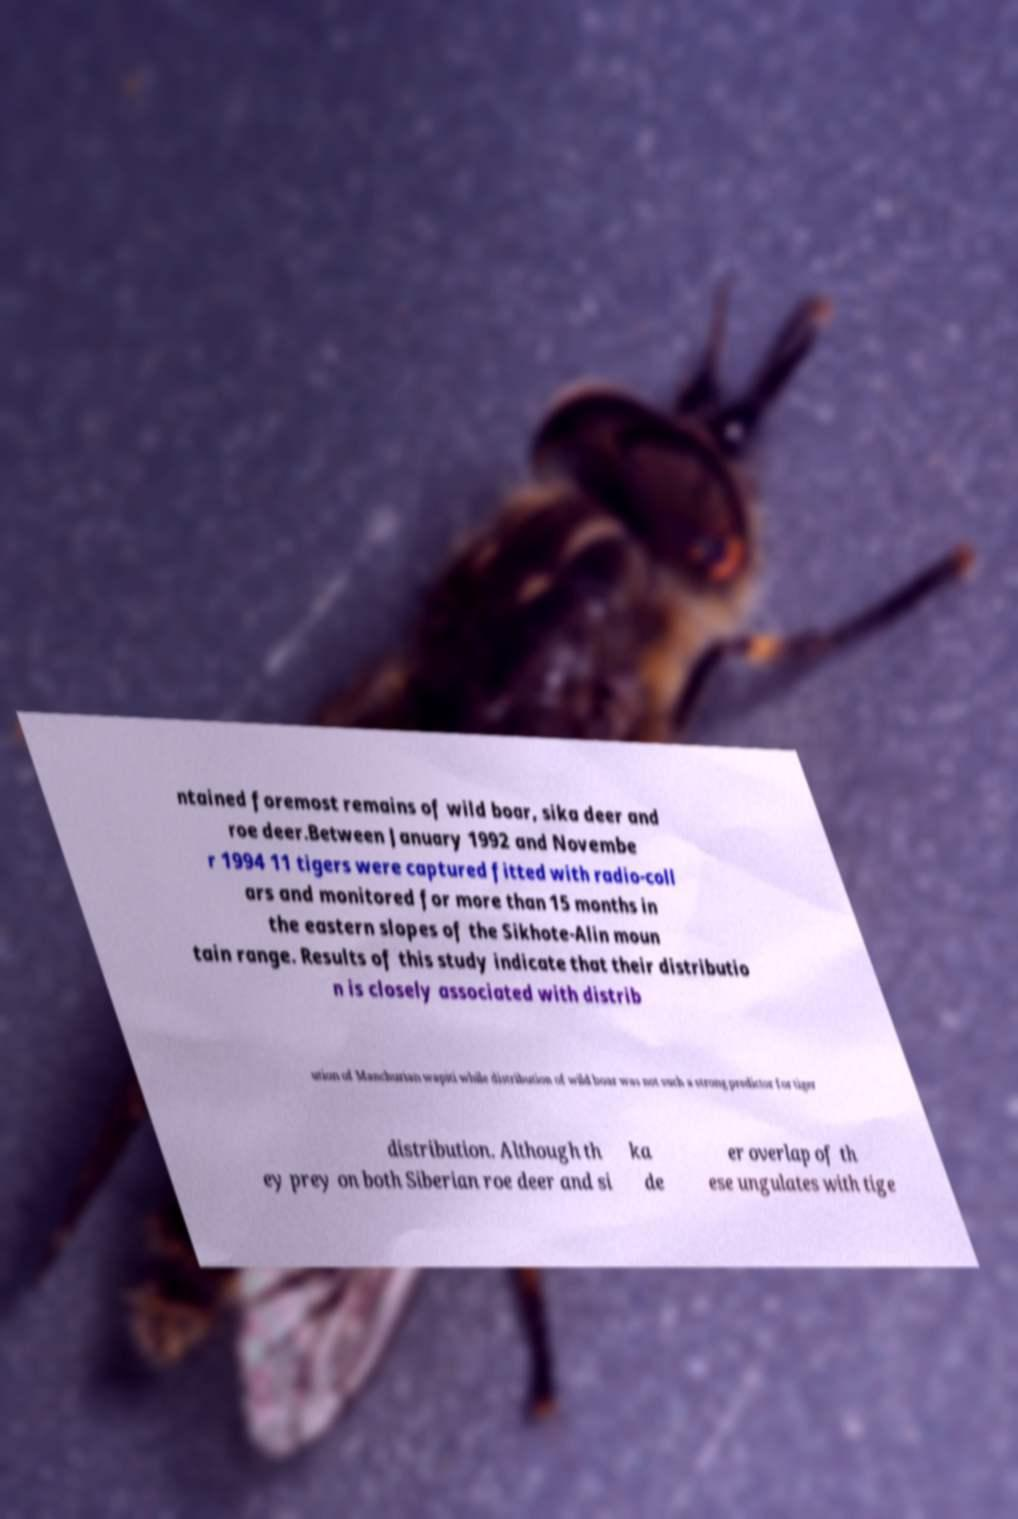I need the written content from this picture converted into text. Can you do that? ntained foremost remains of wild boar, sika deer and roe deer.Between January 1992 and Novembe r 1994 11 tigers were captured fitted with radio-coll ars and monitored for more than 15 months in the eastern slopes of the Sikhote-Alin moun tain range. Results of this study indicate that their distributio n is closely associated with distrib ution of Manchurian wapiti while distribution of wild boar was not such a strong predictor for tiger distribution. Although th ey prey on both Siberian roe deer and si ka de er overlap of th ese ungulates with tige 